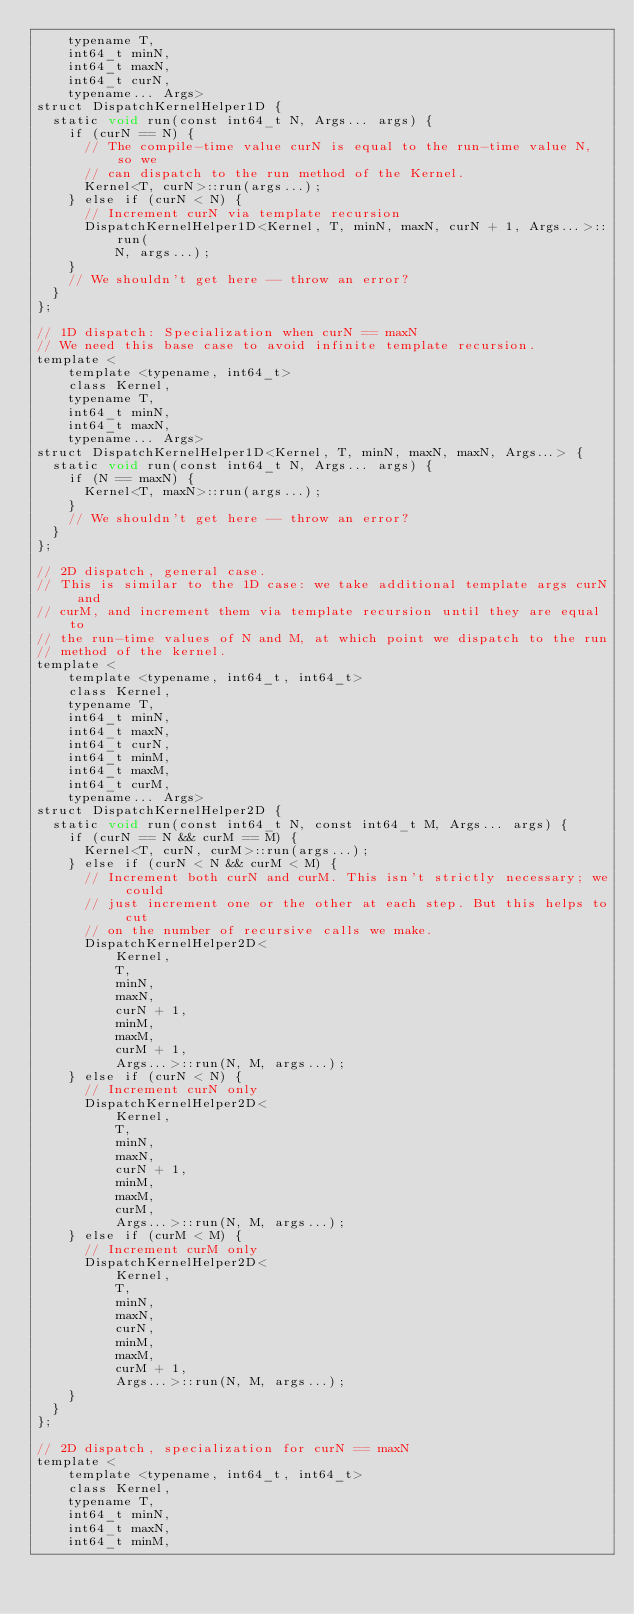Convert code to text. <code><loc_0><loc_0><loc_500><loc_500><_Cuda_>    typename T,
    int64_t minN,
    int64_t maxN,
    int64_t curN,
    typename... Args>
struct DispatchKernelHelper1D {
  static void run(const int64_t N, Args... args) {
    if (curN == N) {
      // The compile-time value curN is equal to the run-time value N, so we
      // can dispatch to the run method of the Kernel.
      Kernel<T, curN>::run(args...);
    } else if (curN < N) {
      // Increment curN via template recursion
      DispatchKernelHelper1D<Kernel, T, minN, maxN, curN + 1, Args...>::run(
          N, args...);
    }
    // We shouldn't get here -- throw an error?
  }
};

// 1D dispatch: Specialization when curN == maxN
// We need this base case to avoid infinite template recursion.
template <
    template <typename, int64_t>
    class Kernel,
    typename T,
    int64_t minN,
    int64_t maxN,
    typename... Args>
struct DispatchKernelHelper1D<Kernel, T, minN, maxN, maxN, Args...> {
  static void run(const int64_t N, Args... args) {
    if (N == maxN) {
      Kernel<T, maxN>::run(args...);
    }
    // We shouldn't get here -- throw an error?
  }
};

// 2D dispatch, general case.
// This is similar to the 1D case: we take additional template args curN and
// curM, and increment them via template recursion until they are equal to
// the run-time values of N and M, at which point we dispatch to the run
// method of the kernel.
template <
    template <typename, int64_t, int64_t>
    class Kernel,
    typename T,
    int64_t minN,
    int64_t maxN,
    int64_t curN,
    int64_t minM,
    int64_t maxM,
    int64_t curM,
    typename... Args>
struct DispatchKernelHelper2D {
  static void run(const int64_t N, const int64_t M, Args... args) {
    if (curN == N && curM == M) {
      Kernel<T, curN, curM>::run(args...);
    } else if (curN < N && curM < M) {
      // Increment both curN and curM. This isn't strictly necessary; we could
      // just increment one or the other at each step. But this helps to cut
      // on the number of recursive calls we make.
      DispatchKernelHelper2D<
          Kernel,
          T,
          minN,
          maxN,
          curN + 1,
          minM,
          maxM,
          curM + 1,
          Args...>::run(N, M, args...);
    } else if (curN < N) {
      // Increment curN only
      DispatchKernelHelper2D<
          Kernel,
          T,
          minN,
          maxN,
          curN + 1,
          minM,
          maxM,
          curM,
          Args...>::run(N, M, args...);
    } else if (curM < M) {
      // Increment curM only
      DispatchKernelHelper2D<
          Kernel,
          T,
          minN,
          maxN,
          curN,
          minM,
          maxM,
          curM + 1,
          Args...>::run(N, M, args...);
    }
  }
};

// 2D dispatch, specialization for curN == maxN
template <
    template <typename, int64_t, int64_t>
    class Kernel,
    typename T,
    int64_t minN,
    int64_t maxN,
    int64_t minM,</code> 